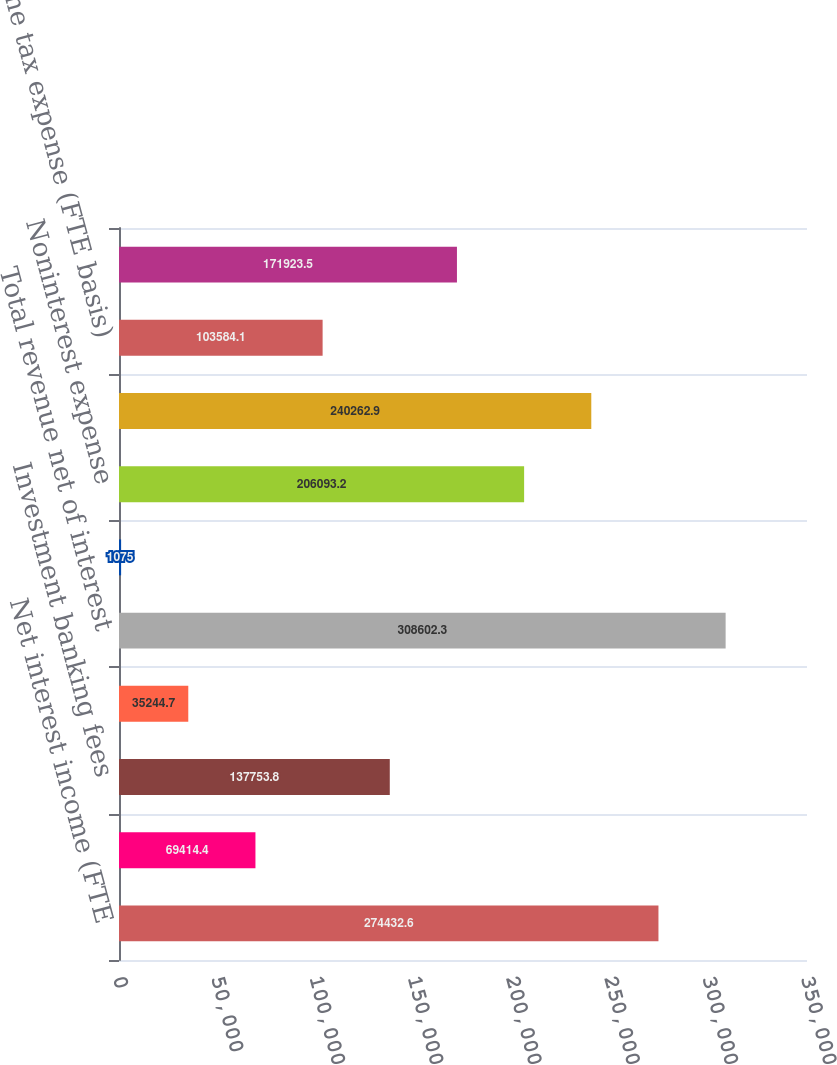Convert chart to OTSL. <chart><loc_0><loc_0><loc_500><loc_500><bar_chart><fcel>Net interest income (FTE<fcel>Service charges<fcel>Investment banking fees<fcel>All other income<fcel>Total revenue net of interest<fcel>Provision for credit losses<fcel>Noninterest expense<fcel>Income before income taxes<fcel>Income tax expense (FTE basis)<fcel>Net income<nl><fcel>274433<fcel>69414.4<fcel>137754<fcel>35244.7<fcel>308602<fcel>1075<fcel>206093<fcel>240263<fcel>103584<fcel>171924<nl></chart> 